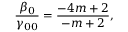Convert formula to latex. <formula><loc_0><loc_0><loc_500><loc_500>{ \frac { \beta _ { 0 } } { \gamma _ { 0 0 } } } = { \frac { - 4 m + 2 } { - m + 2 } } ,</formula> 